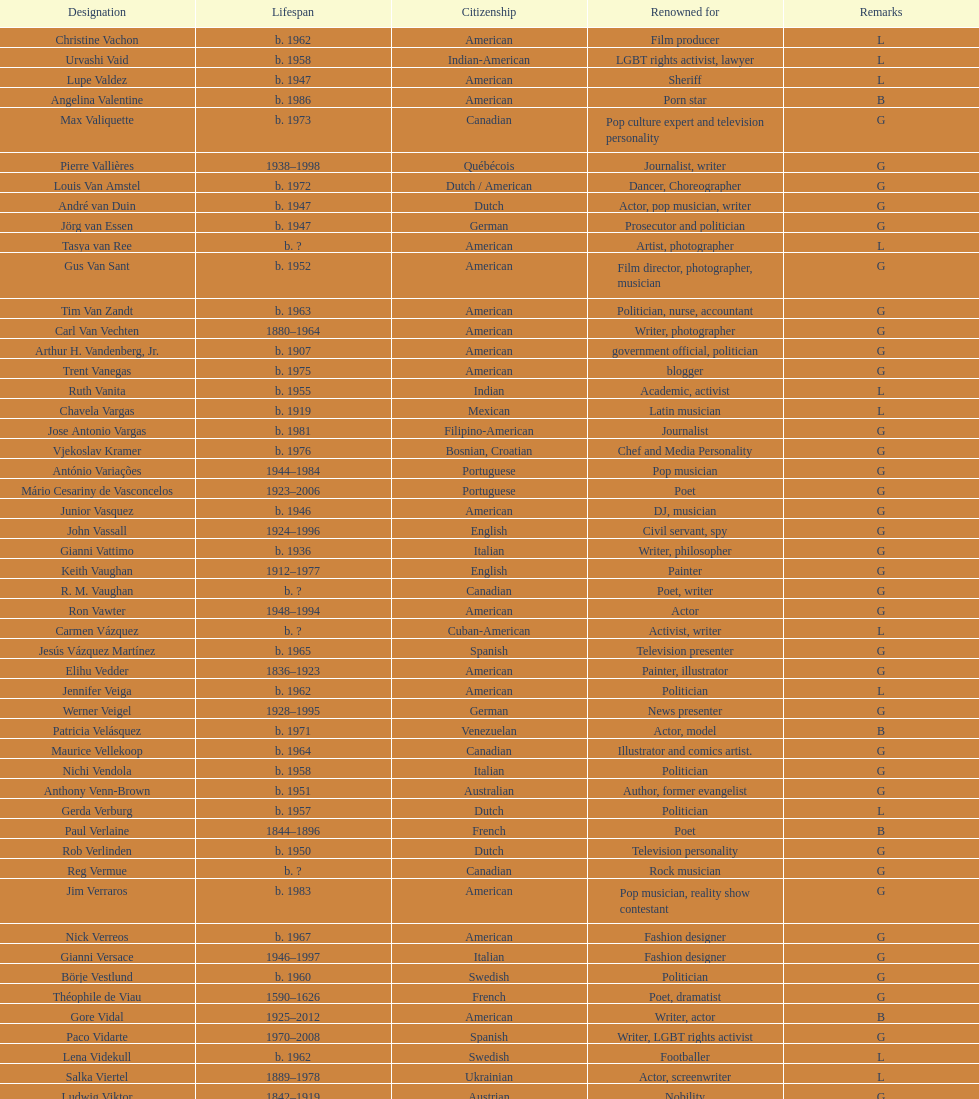Which nationality has the most people associated with it? American. 